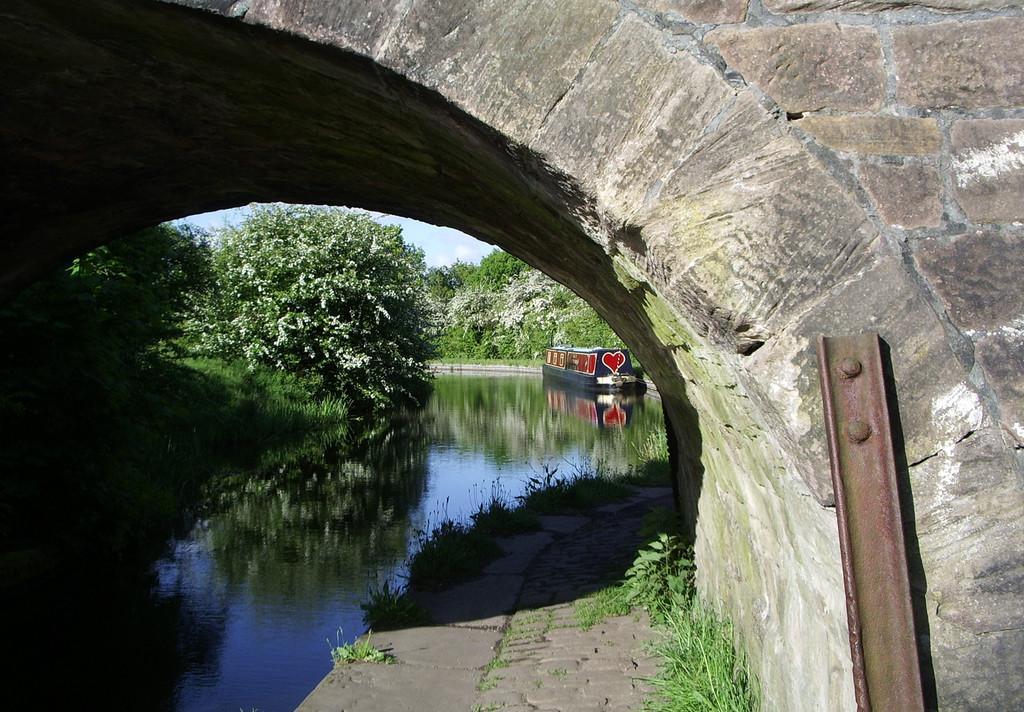How would you summarize this image in a sentence or two? In this image we can see an arch. Also there is water. On the water there is a boat. In the background there are trees. Also there is sky. On the right side we can see an iron rod. 